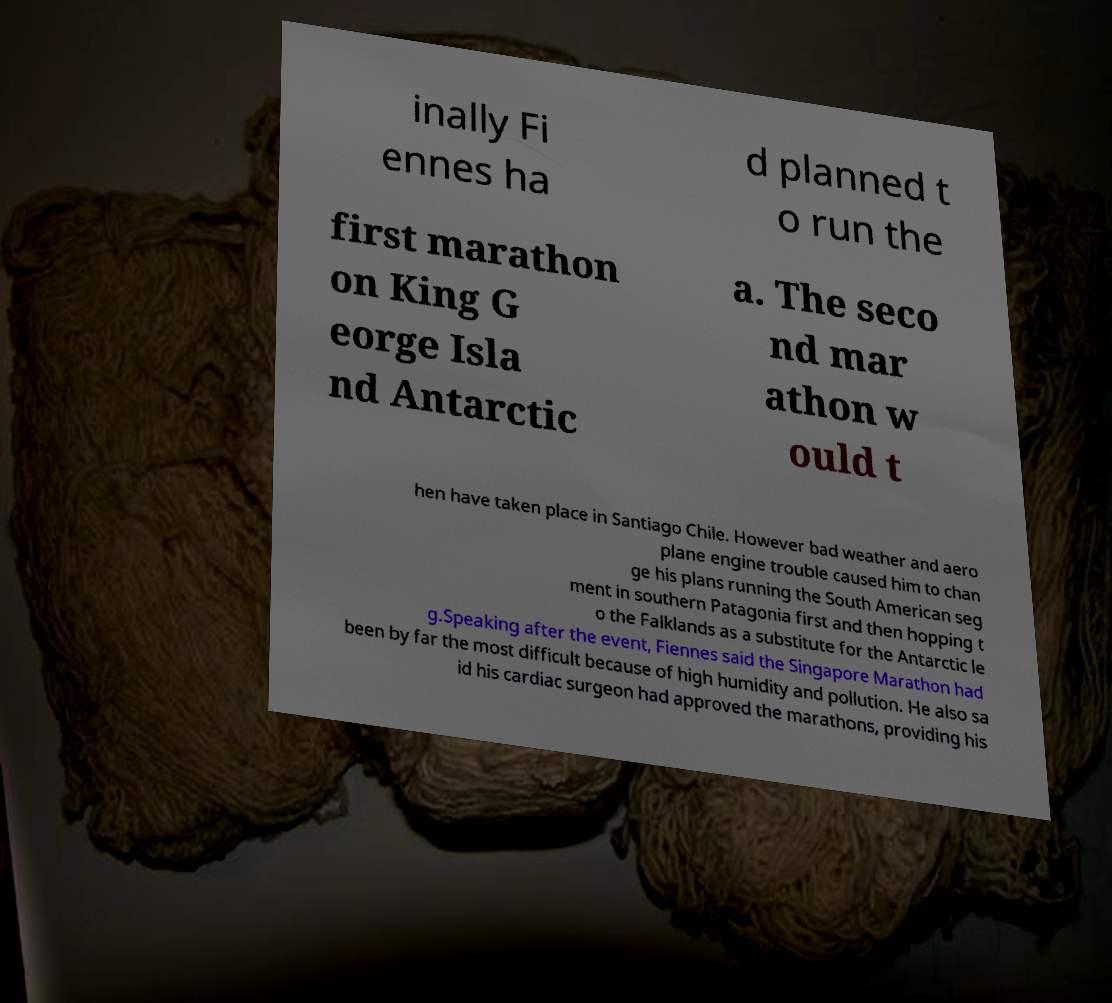There's text embedded in this image that I need extracted. Can you transcribe it verbatim? inally Fi ennes ha d planned t o run the first marathon on King G eorge Isla nd Antarctic a. The seco nd mar athon w ould t hen have taken place in Santiago Chile. However bad weather and aero plane engine trouble caused him to chan ge his plans running the South American seg ment in southern Patagonia first and then hopping t o the Falklands as a substitute for the Antarctic le g.Speaking after the event, Fiennes said the Singapore Marathon had been by far the most difficult because of high humidity and pollution. He also sa id his cardiac surgeon had approved the marathons, providing his 